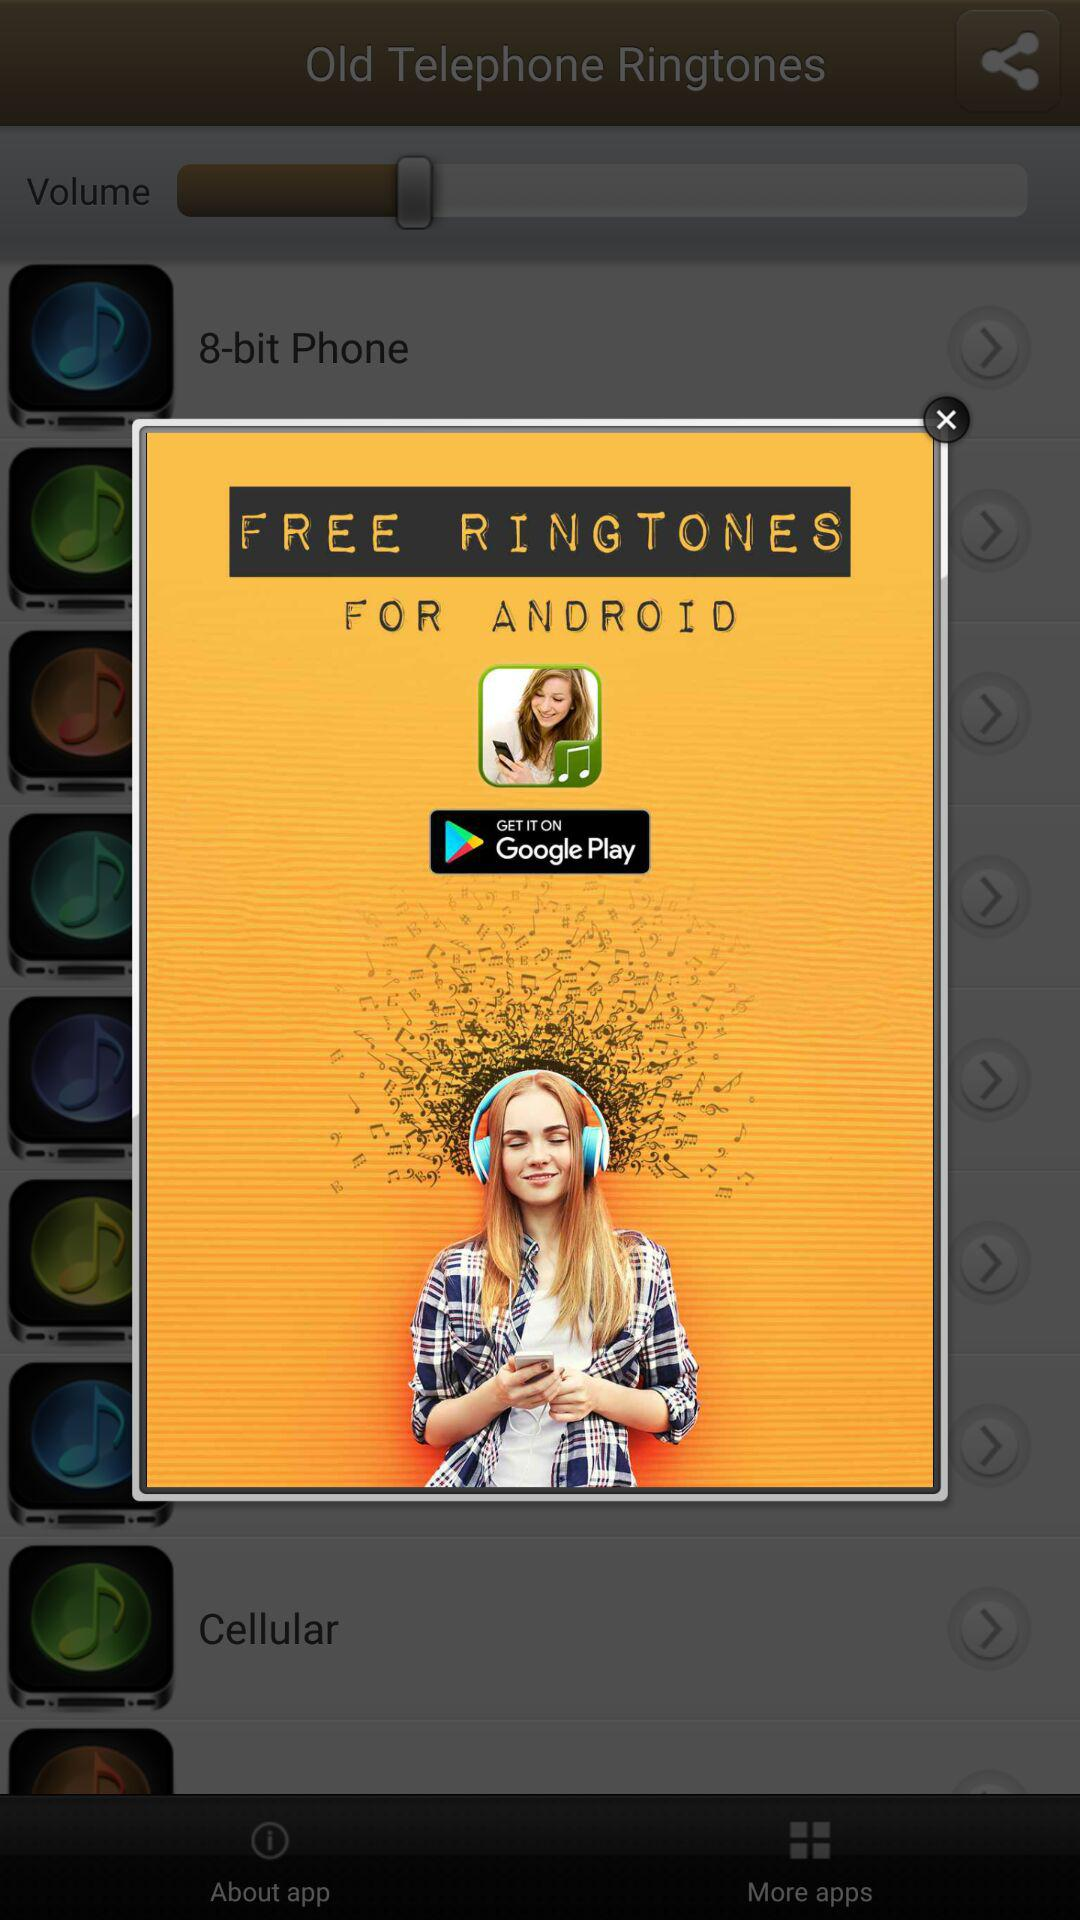What is the name of the application? The name of the application is "FREE RINGTONES". 